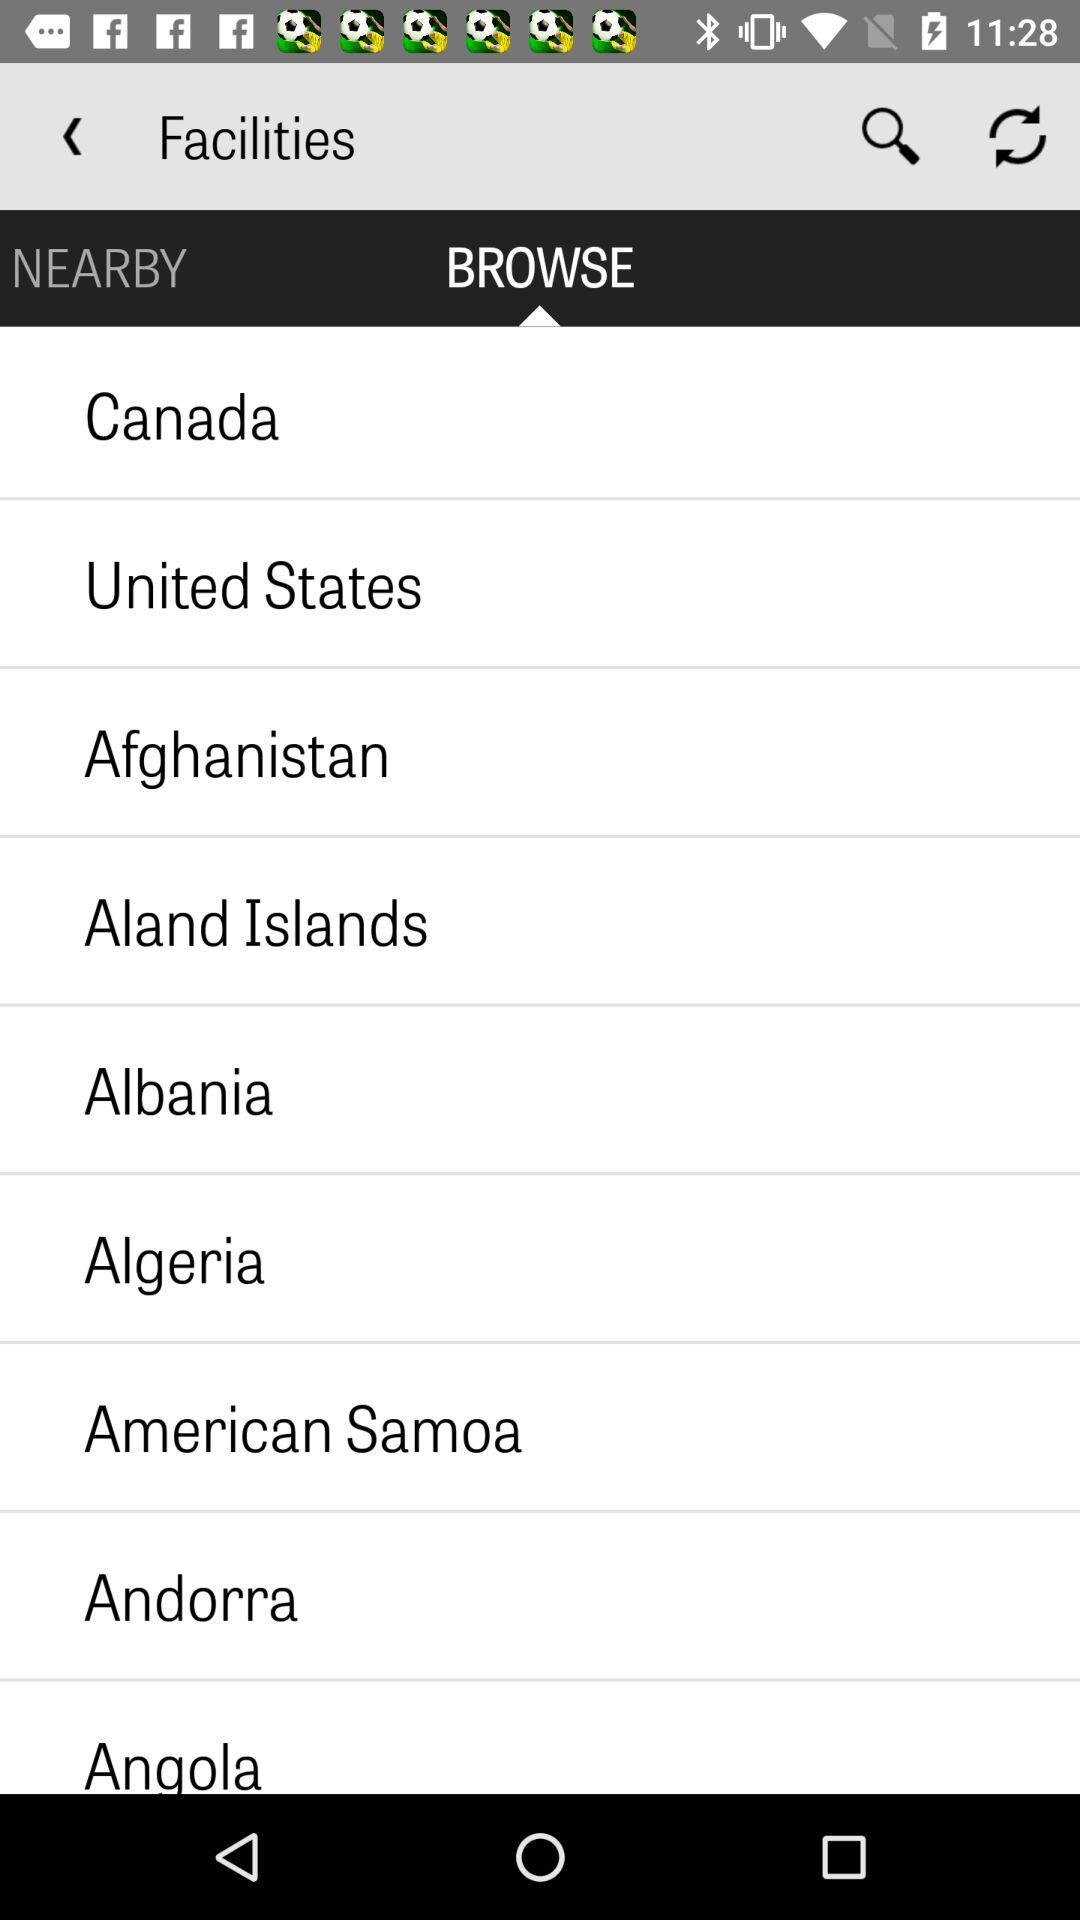Which tab am I on? You are on "BROWSE" tab. 